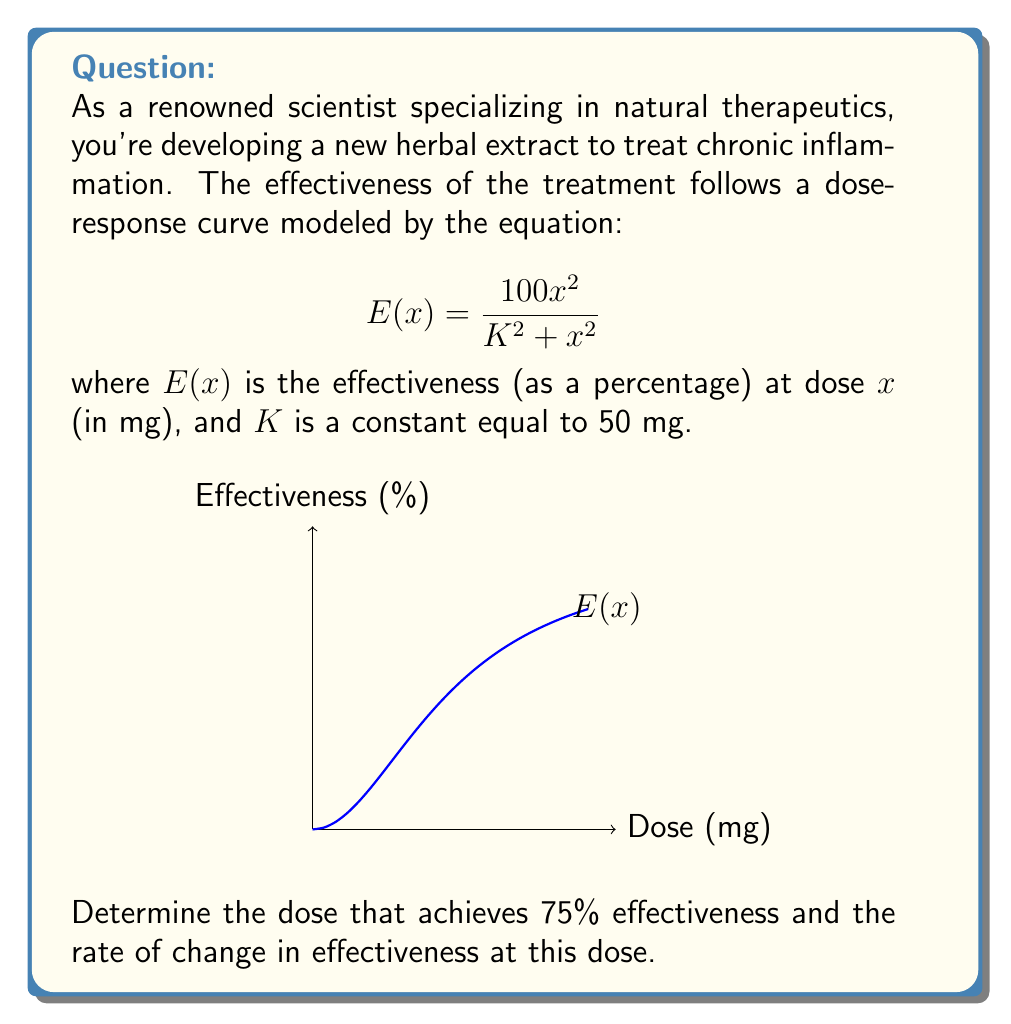Can you solve this math problem? Let's approach this step-by-step:

1) To find the dose for 75% effectiveness, we set $E(x) = 75$ and solve for $x$:

   $$75 = \frac{100x^2}{2500 + x^2}$$

2) Multiply both sides by $(2500 + x^2)$:

   $$75(2500 + x^2) = 100x^2$$

3) Expand:

   $$187500 + 75x^2 = 100x^2$$

4) Subtract $75x^2$ from both sides:

   $$187500 = 25x^2$$

5) Divide both sides by 25:

   $$7500 = x^2$$

6) Take the square root of both sides:

   $$x = \sqrt{7500} = 50\sqrt{3} \approx 86.60 \text{ mg}$$

7) To find the rate of change at this dose, we need to differentiate $E(x)$ and evaluate at $x = 50\sqrt{3}$:

   $$E'(x) = \frac{200x(K^2 + x^2) - 100x^2(2x)}{(K^2 + x^2)^2} = \frac{200xK^2}{(K^2 + x^2)^2}$$

8) Substitute $K = 50$ and $x = 50\sqrt{3}$:

   $$E'(50\sqrt{3}) = \frac{200(50\sqrt{3})(50^2)}{(50^2 + (50\sqrt{3})^2)^2} = \frac{500000\sqrt{3}}{(2500 + 7500)^2} = \frac{500000\sqrt{3}}{100000000} = \frac{\sqrt{3}}{200} \approx 0.00866 \text{ %/mg}$$
Answer: Dose: $50\sqrt{3}$ mg; Rate of change: $\frac{\sqrt{3}}{200}$ %/mg 